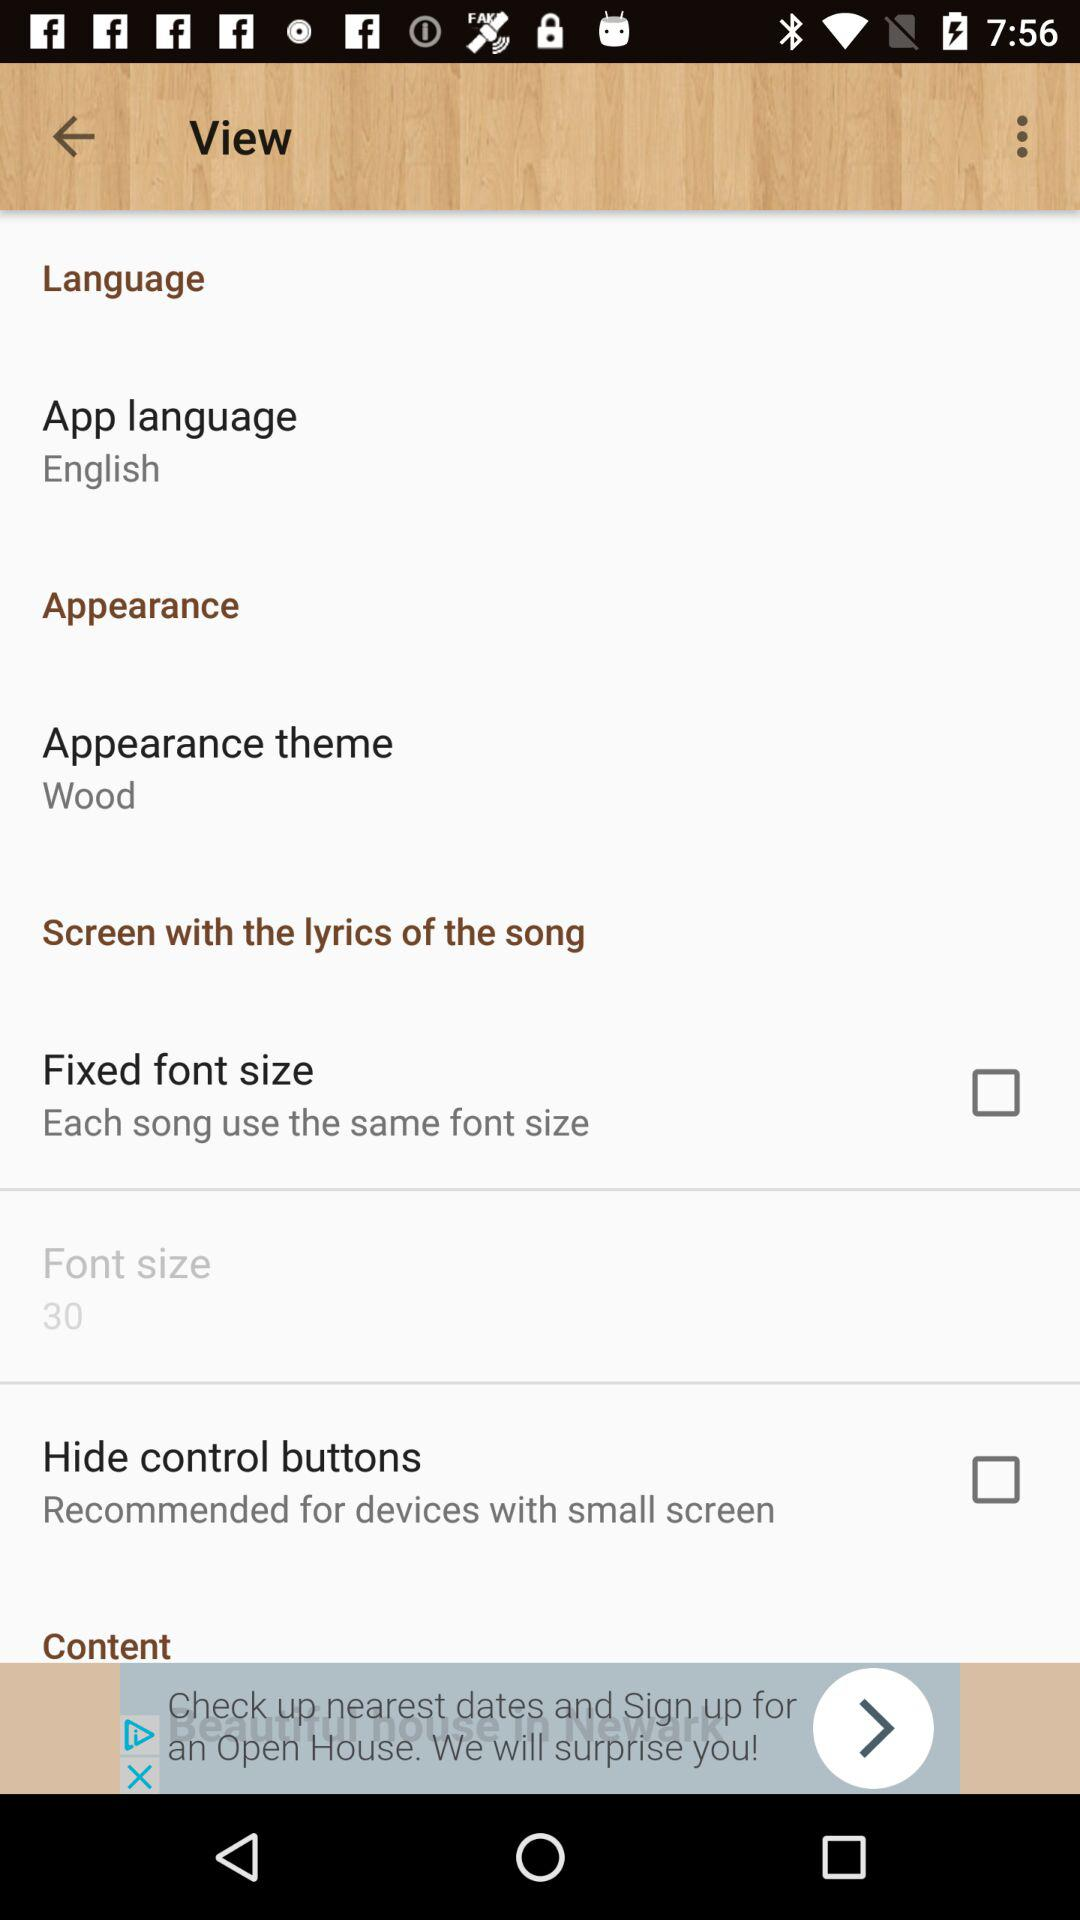What is the appearance theme? The appearance theme is "Wood". 